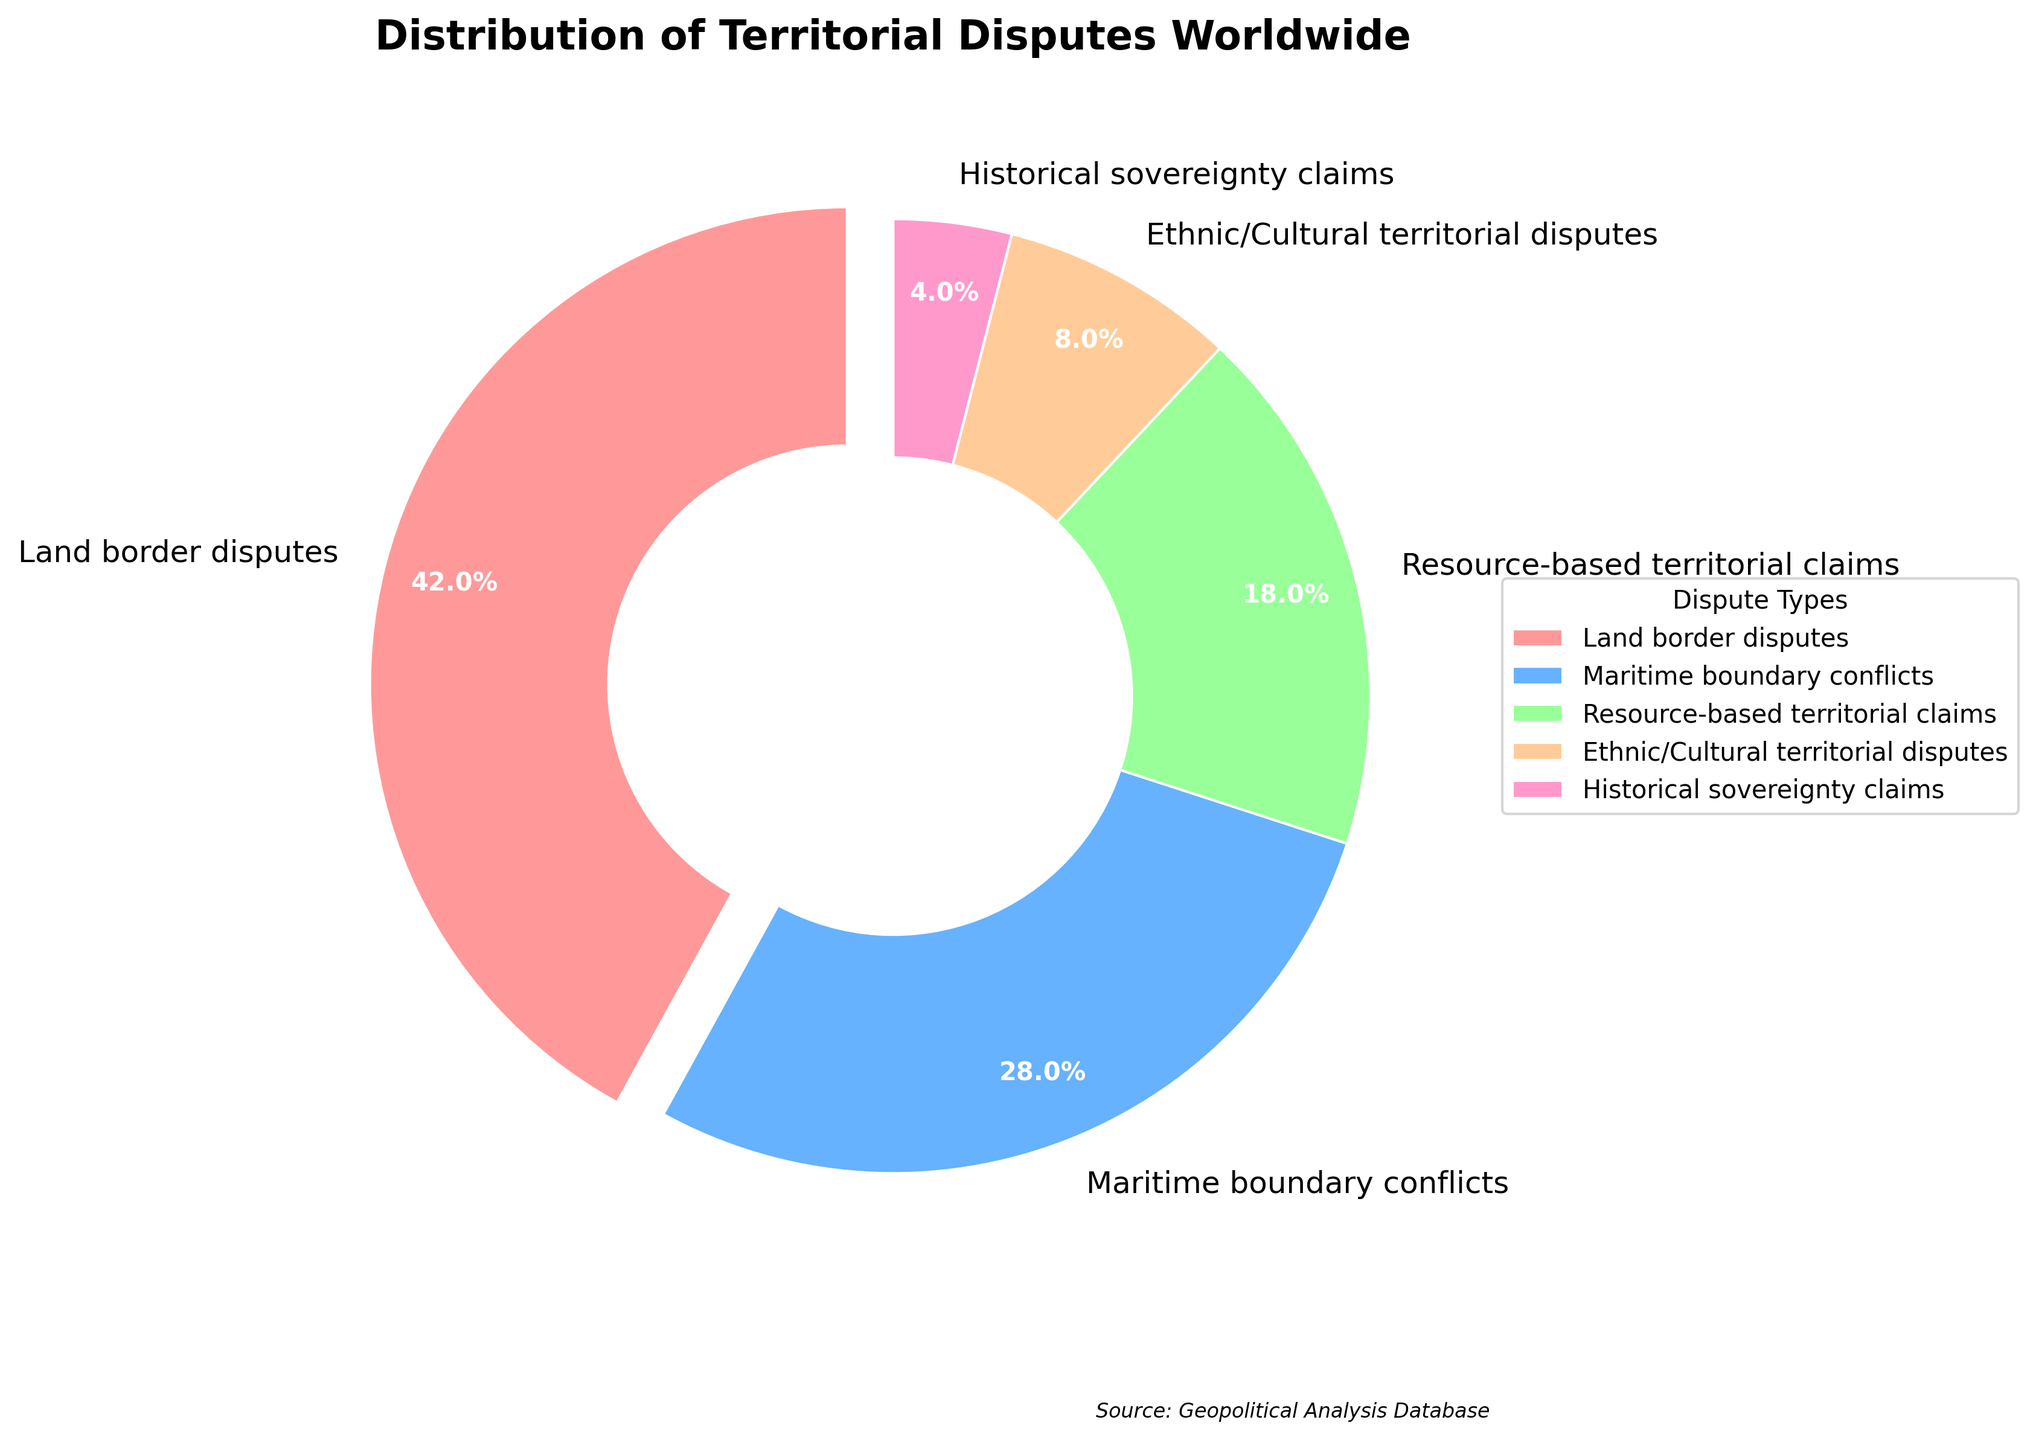Which type of territorial dispute has the largest percentage? By looking at the segment with the largest size, we can identify the "Land border disputes" as having the largest percentage. The label shows it constitutes 42% of the total.
Answer: Land border disputes Between "Maritime boundary conflicts" and "Resource-based territorial claims," which type of dispute is more common? Comparing the sizes of the segments, we see that "Maritime boundary conflicts" occupy a larger portion of the pie chart than "Resource-based territorial claims."
Answer: Maritime boundary conflicts What is the total percentage of "Ethnic/Cultural territorial disputes" and "Historical sovereignty claims"? Adding the percentages of both disputes: 8% (Ethnic/Cultural territorial disputes) + 4% (Historical sovereignty claims) = 12%.
Answer: 12% How much larger is the percentage of "Land border disputes" compared to "Maritime boundary conflicts"? Subtract the percentage of "Maritime boundary conflicts" from that of "Land border disputes": 42% (Land border disputes) - 28% (Maritime boundary conflicts) = 14%.
Answer: 14% What color represents the "Resource-based territorial claims" in the pie chart? By observing the color legend and matching it with the chart, we note that "Resource-based territorial claims" is shown in green.
Answer: Green If we group all non-"Land border disputes," what percentage do they represent together? Summing the percentages of Maritime boundary conflicts (28%), Resource-based territorial claims (18%), Ethnic/Cultural territorial disputes (8%), and Historical sovereignty claims (4%): 28% + 18% + 8% + 4% = 58%.
Answer: 58% What is the combined percentage of "Maritime boundary conflicts" and "Resource-based territorial claims"? Adding the percentages of both disputes: 28% (Maritime boundary conflicts) + 18% (Resource-based territorial claims) = 46%.
Answer: 46% Which sector is smallest in terms of percentage and what is its color? By comparing the sizes and labels of the segments, we see that "Historical sovereignty claims" is the smallest with 4%, represented in pink.
Answer: Historical sovereignty claims, pink Among all types of territorial disputes, which constitutes less than 10%? Referencing the pie chart, "Ethnic/Cultural territorial disputes" (8%) and "Historical sovereignty claims" (4%) are the ones below 10%.
Answer: Ethnic/Cultural territorial disputes and Historical sovereignty claims 